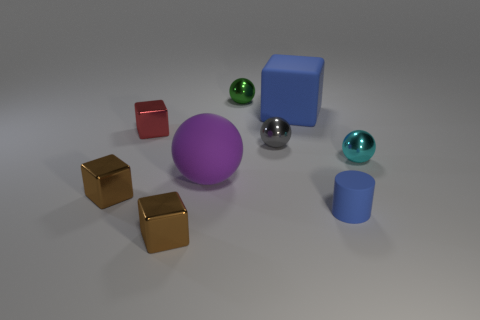How many things are either metal objects right of the purple sphere or yellow objects? Including all the metal objects to the right of the purple sphere, there are two: a small silver sphere and a green teal-like sphere. Furthermore, we also have three yellow cube-shaped objects. Therefore, in total, there are five objects that either fulfill the condition of being metal and to the right of the purple sphere or are yellow objects. 